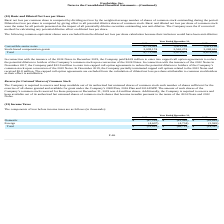According to Everbridge's financial document, How is basic net loss per common share computed? by dividing net loss by the weighted-average number of shares of common stock outstanding during the period.. The document states: "Basic net loss per common share is computed by dividing net loss by the weighted-average number of shares of common stock outstanding during the perio..." Also, can you calculate: What is the average Convertible senior notes for the period December 31, 2019 to December 31, 2018? To answer this question, I need to perform calculations using the financial data. The calculation is: (6,733,914+3,411,199) / 2, which equals 5072556.5. This is based on the information: "Convertible senior notes 6,733,914 3,411,199 3,411,199 Convertible senior notes 6,733,914 3,411,199 3,411,199..." The key data points involved are: 3,411,199, 6,733,914. Also, can you calculate: What is the average Stock-based compensation grants for the period December 31, 2019 to December 31, 2018? To answer this question, I need to perform calculations using the financial data. The calculation is: (2,038,174+2,562,274) / 2, which equals 2300224. This is based on the information: "Stock-based compensation grants 2,038,174 2,562,274 3,268,610 Stock-based compensation grants 2,038,174 2,562,274 3,268,610..." The key data points involved are: 2,038,174, 2,562,274. Additionally, In which year was Convertible senior notes less than 4,000,000? The document shows two values: 2018 and 2017. Locate and analyze convertible senior notes in row 3. From the document: "2019 2018 2017 2019 2018 2017..." Also, What was Stock-based compensation grants in 2019, 2018 and 2017 respectively? The document contains multiple relevant values: 2,038,174, 2,562,274, 3,268,610. From the document: "Stock-based compensation grants 2,038,174 2,562,274 3,268,610 ock-based compensation grants 2,038,174 2,562,274 3,268,610 Stock-based compensation gra..." Also, What was the amount paid by the company to enter into capped call option agreements to reduce the potential dilution? According to the financial document, $44.9 million. The relevant text states: "the 2024 Notes in December 2019, the Company paid $44.9 million to enter into capped call option agreements to reduce the potential dilution to holders of the Compa..." 